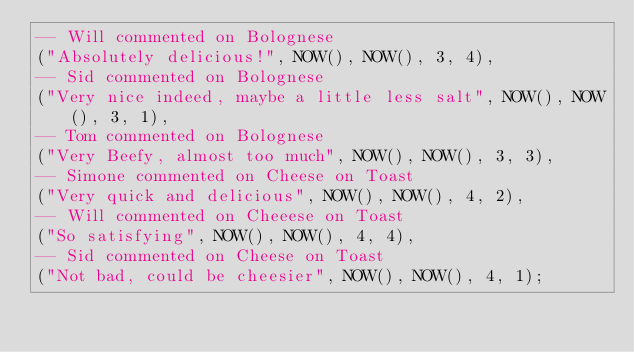<code> <loc_0><loc_0><loc_500><loc_500><_SQL_>-- Will commented on Bolognese
("Absolutely delicious!", NOW(), NOW(), 3, 4),
-- Sid commented on Bolognese
("Very nice indeed, maybe a little less salt", NOW(), NOW(), 3, 1),
-- Tom commented on Bolognese
("Very Beefy, almost too much", NOW(), NOW(), 3, 3),
-- Simone commented on Cheese on Toast
("Very quick and delicious", NOW(), NOW(), 4, 2),
-- Will commented on Cheeese on Toast
("So satisfying", NOW(), NOW(), 4, 4),
-- Sid commented on Cheese on Toast
("Not bad, could be cheesier", NOW(), NOW(), 4, 1);
</code> 